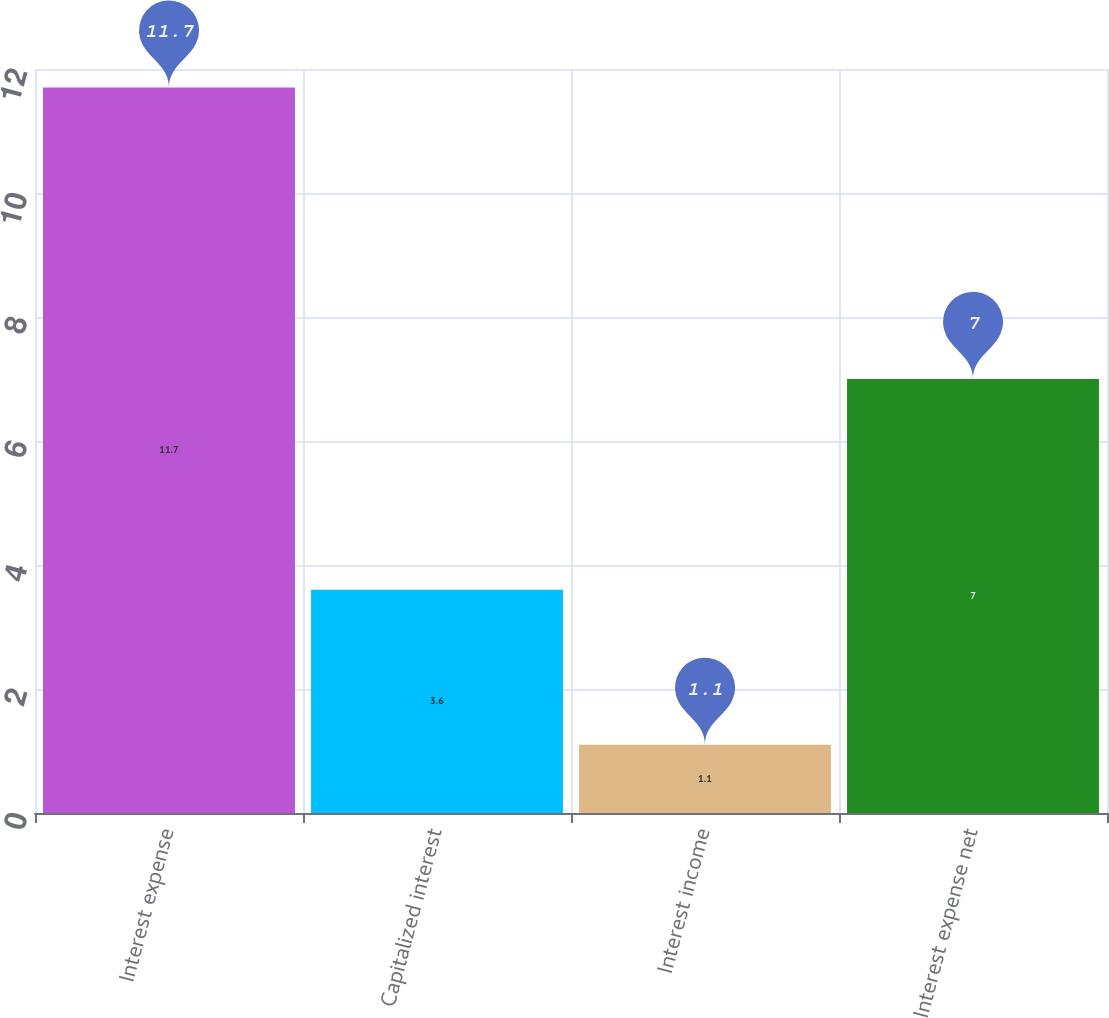Convert chart. <chart><loc_0><loc_0><loc_500><loc_500><bar_chart><fcel>Interest expense<fcel>Capitalized interest<fcel>Interest income<fcel>Interest expense net<nl><fcel>11.7<fcel>3.6<fcel>1.1<fcel>7<nl></chart> 